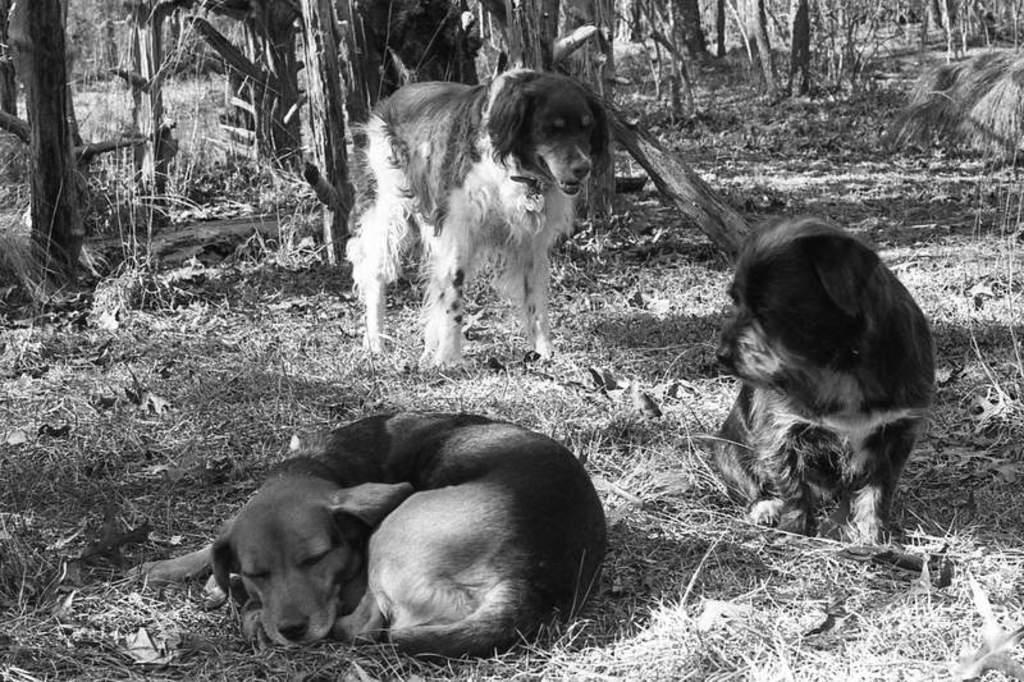Describe this image in one or two sentences. This is a black and white image. On the left there is a dog sleeping on the ground. On the right there is another dog sitting on the ground. In the center we can see a dog standing on the ground. In the background we can see the trunks of the trees and the grass. 